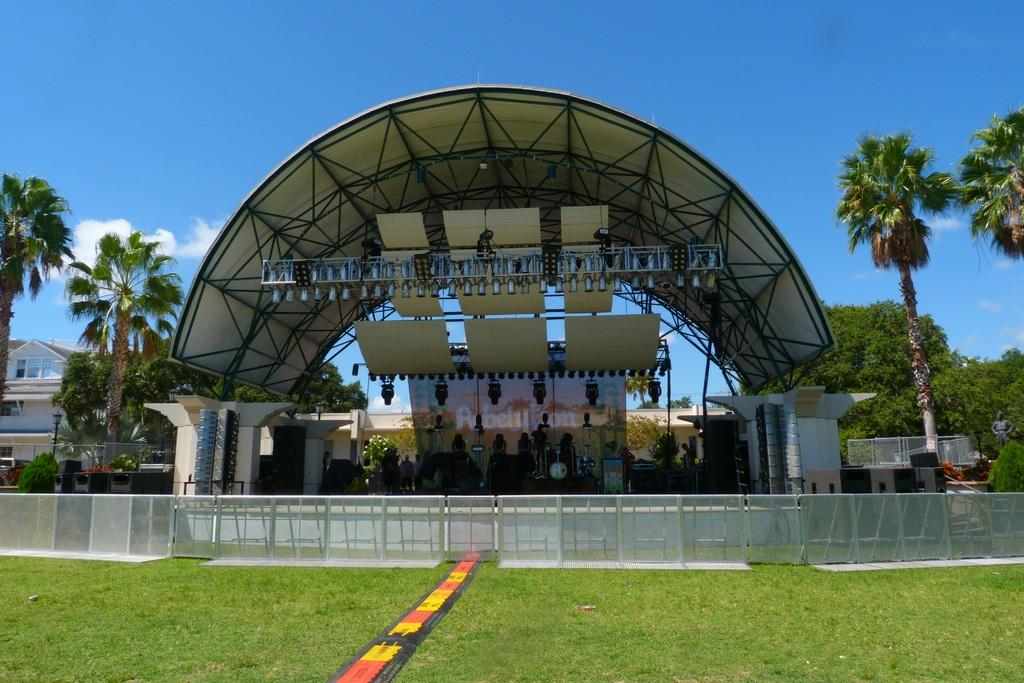Where are the people located in the image? The people are under a curved roof in the image. What can be seen hanging from the roof? There are objects hanging from the roof in the image. What type of natural elements are present in the image? There are trees and grass in the image. What type of structures can be seen in the image? There are buildings and a fence in the image. What is visible in the sky in the image? There are clouds in the sky in the image. What color of ink is being used to write on the trees in the image? There is no ink or writing present on the trees in the image. Is there a battle taking place between the people under the curved roof in the image? There is no indication of a battle or any conflict in the image. 